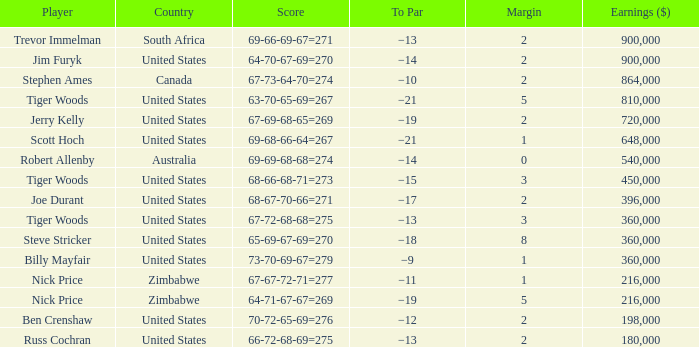How many years has a player comparable to joe durant accumulated, with earnings surpassing $396,000? 0.0. Help me parse the entirety of this table. {'header': ['Player', 'Country', 'Score', 'To Par', 'Margin', 'Earnings ($)'], 'rows': [['Trevor Immelman', 'South Africa', '69-66-69-67=271', '−13', '2', '900,000'], ['Jim Furyk', 'United States', '64-70-67-69=270', '−14', '2', '900,000'], ['Stephen Ames', 'Canada', '67-73-64-70=274', '−10', '2', '864,000'], ['Tiger Woods', 'United States', '63-70-65-69=267', '−21', '5', '810,000'], ['Jerry Kelly', 'United States', '67-69-68-65=269', '−19', '2', '720,000'], ['Scott Hoch', 'United States', '69-68-66-64=267', '−21', '1', '648,000'], ['Robert Allenby', 'Australia', '69-69-68-68=274', '−14', '0', '540,000'], ['Tiger Woods', 'United States', '68-66-68-71=273', '−15', '3', '450,000'], ['Joe Durant', 'United States', '68-67-70-66=271', '−17', '2', '396,000'], ['Tiger Woods', 'United States', '67-72-68-68=275', '−13', '3', '360,000'], ['Steve Stricker', 'United States', '65-69-67-69=270', '−18', '8', '360,000'], ['Billy Mayfair', 'United States', '73-70-69-67=279', '−9', '1', '360,000'], ['Nick Price', 'Zimbabwe', '67-67-72-71=277', '−11', '1', '216,000'], ['Nick Price', 'Zimbabwe', '64-71-67-67=269', '−19', '5', '216,000'], ['Ben Crenshaw', 'United States', '70-72-65-69=276', '−12', '2', '198,000'], ['Russ Cochran', 'United States', '66-72-68-69=275', '−13', '2', '180,000']]} 